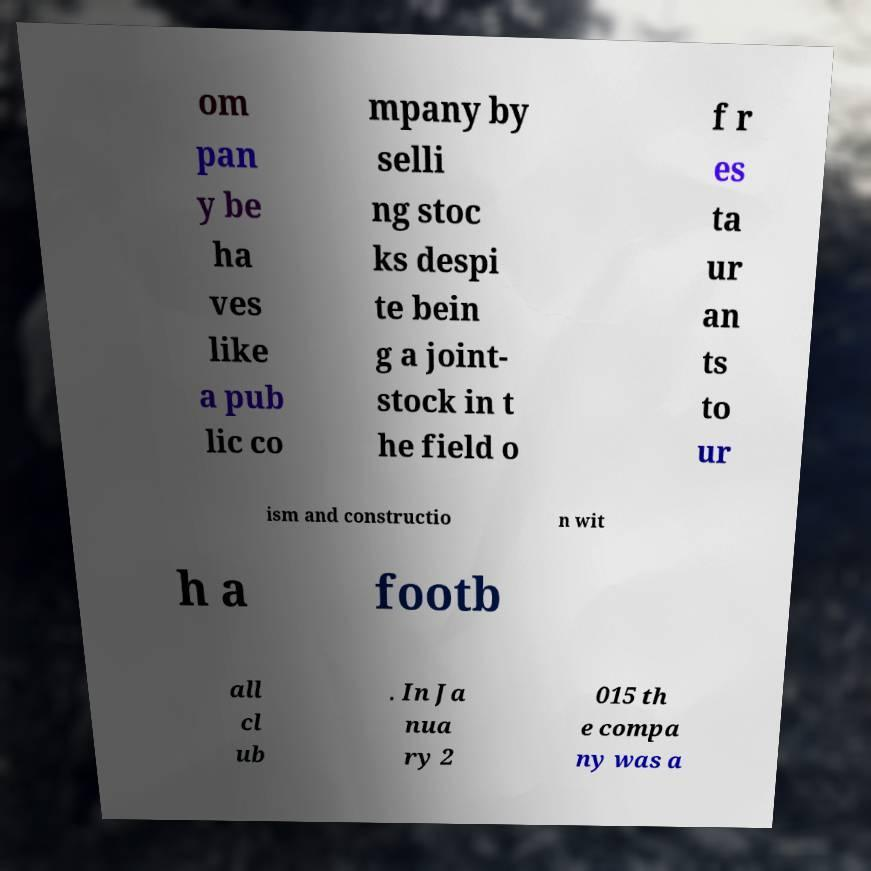Could you extract and type out the text from this image? om pan y be ha ves like a pub lic co mpany by selli ng stoc ks despi te bein g a joint- stock in t he field o f r es ta ur an ts to ur ism and constructio n wit h a footb all cl ub . In Ja nua ry 2 015 th e compa ny was a 